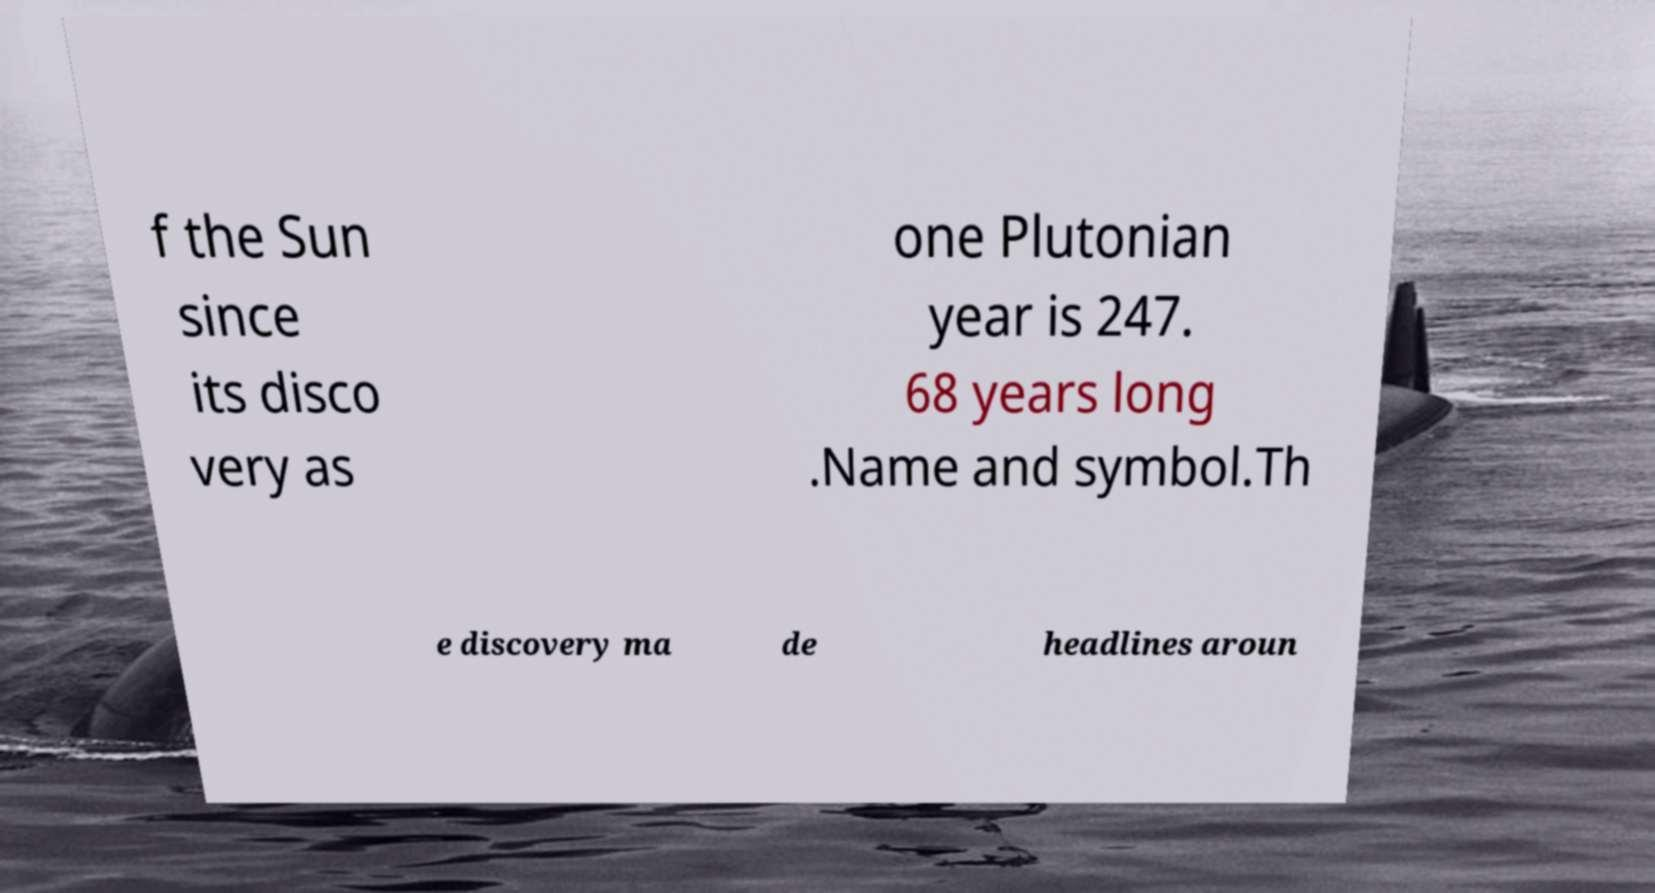For documentation purposes, I need the text within this image transcribed. Could you provide that? f the Sun since its disco very as one Plutonian year is 247. 68 years long .Name and symbol.Th e discovery ma de headlines aroun 